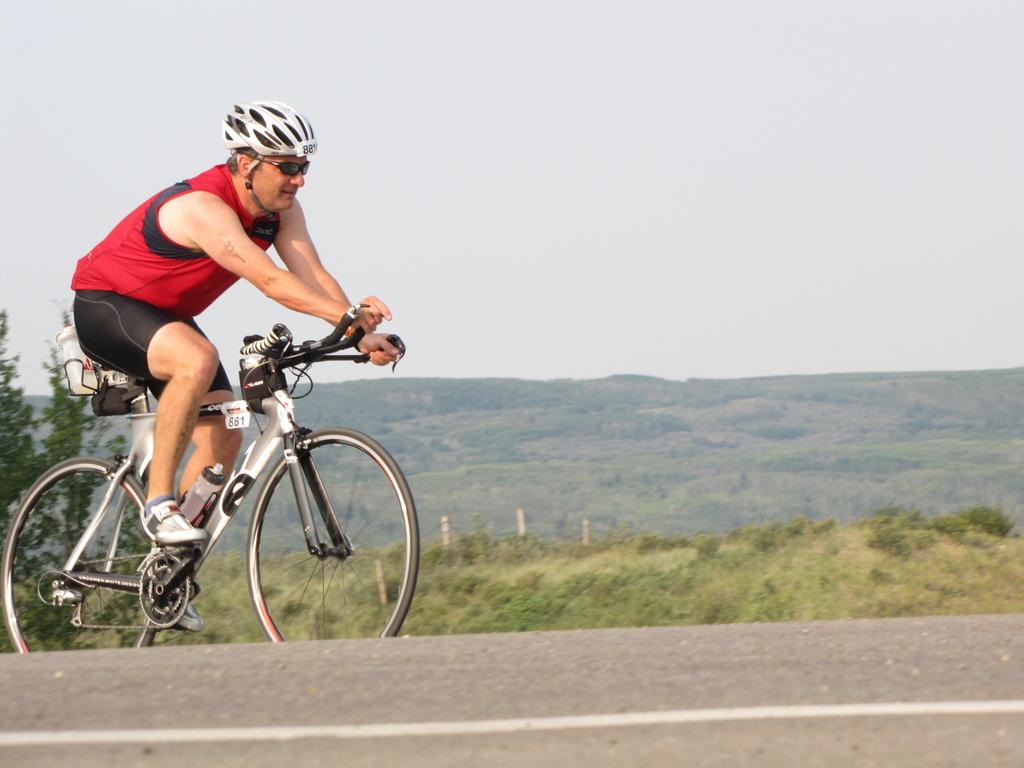What can be seen in the background of the image? There is a sky visible in the background of the image. What is the weather like in the image? It appears to be a sunny day in the image. What type of vegetation is present in the image? There are trees in the image. What type of pathway is visible in the image? There is a road in the image. What is the man in the image doing? The man is riding a bicycle on the road. What safety precaution is the man taking while riding the bicycle? The man is wearing a helmet. What direction is the man riding his bicycle in the image? The provided facts do not indicate the direction the man is riding his bicycle. 